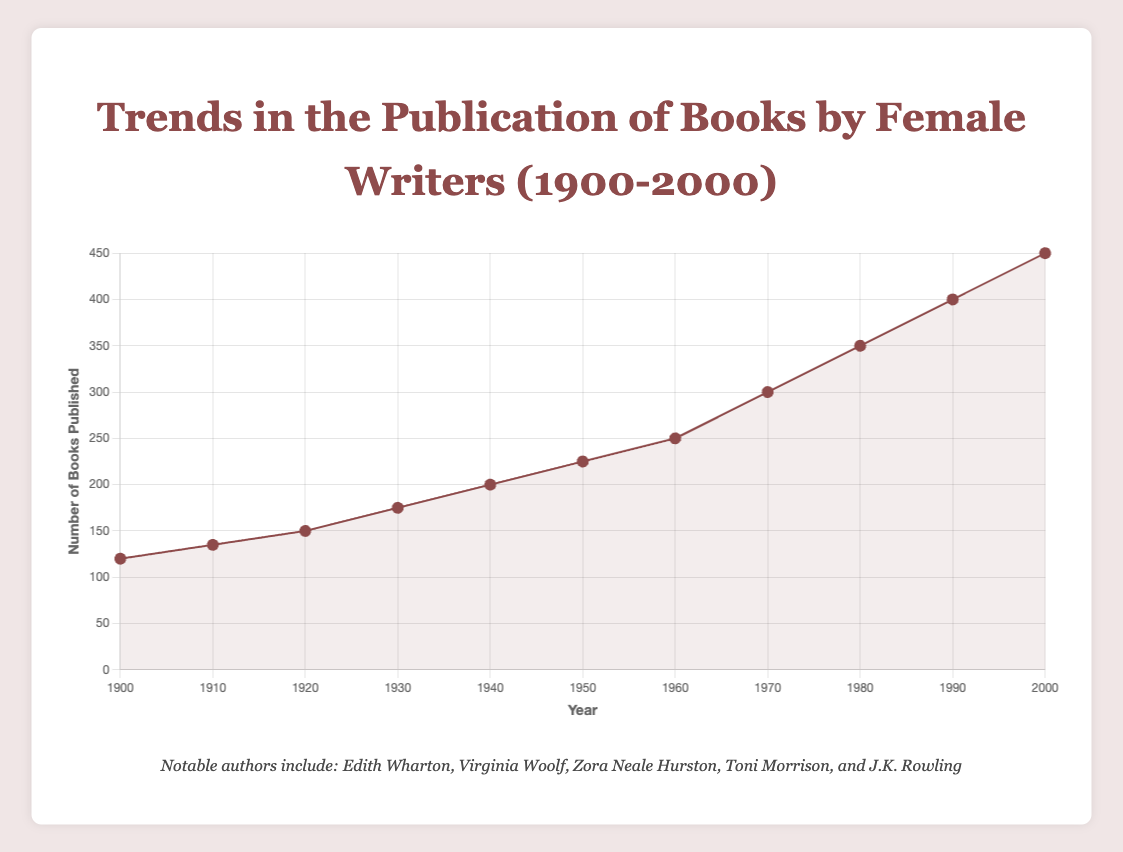What's the trend in the number of books published by female writers from 1900 to 2000? The chart shows a steady increase in the number of books published by female writers over the century, starting from 120 books in 1900 and reaching 450 books in 2000. Observing the line chart's slope, it's clear that publication numbers rose consistently.
Answer: Steady increase Which decade saw the highest increase in the number of books published compared to the previous decade? By comparing the increments between decades, the highest increase is observed between the 1990s and 2000s, where the number of books published went from 400 to 450, an increase of 50 books.
Answer: 1990s to 2000s In which year did the number of books published first reach 300? The number of books published by female writers first reached 300 in 1970, as indicated by the data point in the chart.
Answer: 1970 Compare the number of books published in 1920 and 1950. Which year had more and by how much? In 1920, 150 books were published, while in 1950, 225 books were published. The difference is calculated as 225 - 150 = 75. So, 1950 had 75 more books published.
Answer: 1950; 75 more What is the average number of books published between 1960 and 2000? Summing the books published from 1960 (250), 1970 (300), 1980 (350), 1990 (400), and 2000 (450) gives a total of 1750 books. Dividing by the 5 data points gives an average of 1750 / 5 = 350.
Answer: 350 Which years feature Toni Morrison as a notable author, and how can you identify this from the chart? According to the tooltip information, Toni Morrison is notably mentioned in 1970, 1990, and 2000, indicating her significance in those years.
Answer: 1970, 1990, 2000 How does the number of books published in 1940 compare visually to the number published in 1980? The chart shows that the 1940 data point is at the 200 level, while the 1980 point is at 350, a higher point on the chart indicating more books published.
Answer: 1980 has more What is the total number of books published by female writers between 1900 and 1930? Adding the books published in 1900 (120), 1910 (135), 1920 (150), and 1930 (175), we get a total of 120 + 135 + 150 + 175 = 580 books.
Answer: 580 Which years indicate notable authors who have appeared more than once? Some authors appear in multiple years as notable authors: Edith Wharton appears in 1900, 1910, and 1920, and Virginia Woolf appears in 1920 and 1930.
Answer: 1900, 1910, 1920 (Edith Wharton); 1920, 1930 (Virginia Woolf) Identify the period with the smallest increase in the number of books published. The smallest increase is between 1900 and 1910, where the number of books published went from 120 to 135, an increase of 15.
Answer: 1900 to 1910 